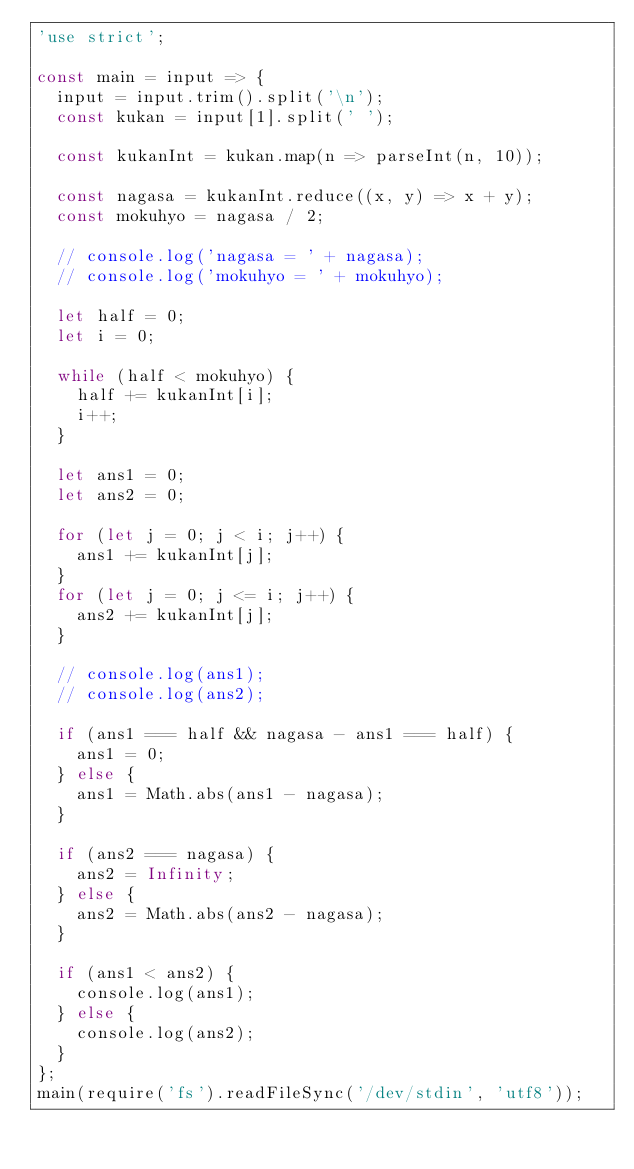<code> <loc_0><loc_0><loc_500><loc_500><_JavaScript_>'use strict';

const main = input => {
  input = input.trim().split('\n');
  const kukan = input[1].split(' ');

  const kukanInt = kukan.map(n => parseInt(n, 10));

  const nagasa = kukanInt.reduce((x, y) => x + y);
  const mokuhyo = nagasa / 2;

  // console.log('nagasa = ' + nagasa);
  // console.log('mokuhyo = ' + mokuhyo);

  let half = 0;
  let i = 0;

  while (half < mokuhyo) {
    half += kukanInt[i];
    i++;
  }

  let ans1 = 0;
  let ans2 = 0;

  for (let j = 0; j < i; j++) {
    ans1 += kukanInt[j];
  }
  for (let j = 0; j <= i; j++) {
    ans2 += kukanInt[j];
  }

  // console.log(ans1);
  // console.log(ans2);

  if (ans1 === half && nagasa - ans1 === half) {
    ans1 = 0;
  } else {
    ans1 = Math.abs(ans1 - nagasa);
  }

  if (ans2 === nagasa) {
    ans2 = Infinity;
  } else {
    ans2 = Math.abs(ans2 - nagasa);
  }

  if (ans1 < ans2) {
    console.log(ans1);
  } else {
    console.log(ans2);
  }
};
main(require('fs').readFileSync('/dev/stdin', 'utf8'));
</code> 